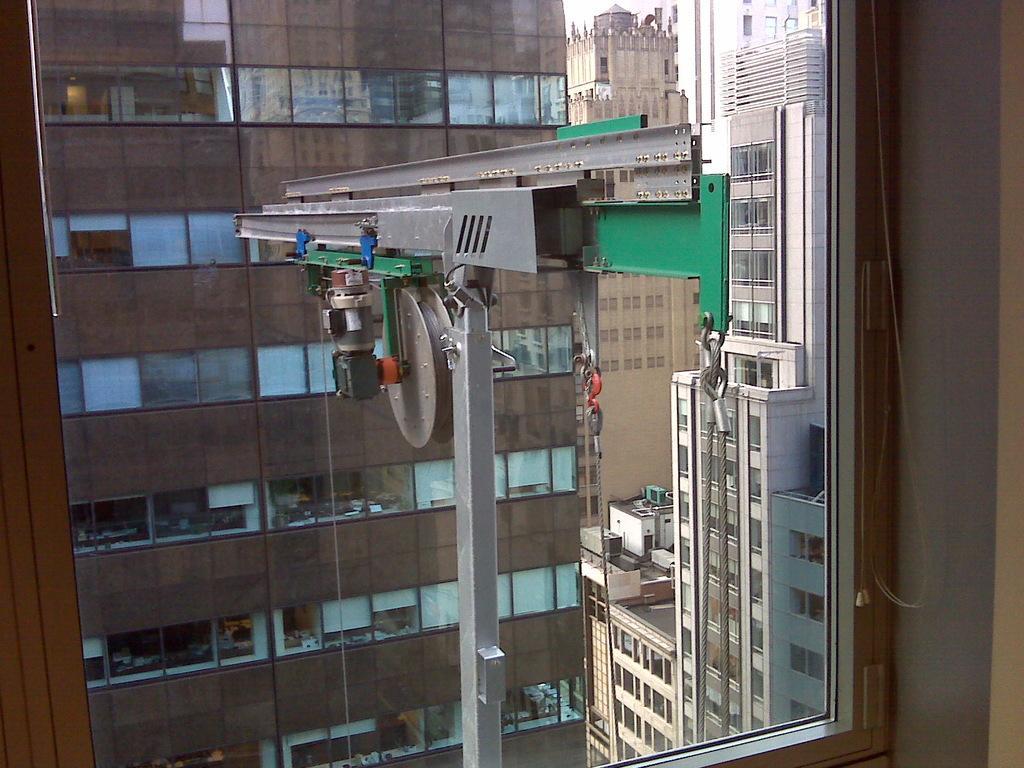How would you summarize this image in a sentence or two? In this image there is a building in the middle. In front of the building there is a weighing machine with the ropes. On the right side there are so many buildings. In the foreground there is a glass through which we can see the buildings. 